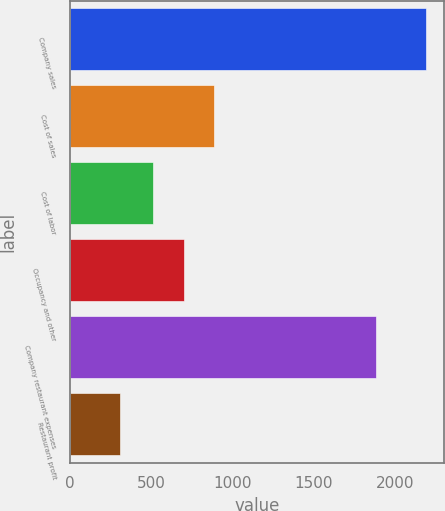<chart> <loc_0><loc_0><loc_500><loc_500><bar_chart><fcel>Company sales<fcel>Cost of sales<fcel>Cost of labor<fcel>Occupancy and other<fcel>Company restaurant expenses<fcel>Restaurant profit<nl><fcel>2191<fcel>887.8<fcel>511<fcel>699.4<fcel>1884<fcel>307<nl></chart> 